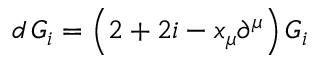Convert formula to latex. <formula><loc_0><loc_0><loc_500><loc_500>d \, G _ { i } = \left ( 2 + 2 i - x _ { \mu } \partial ^ { \mu } \right ) G _ { i }</formula> 